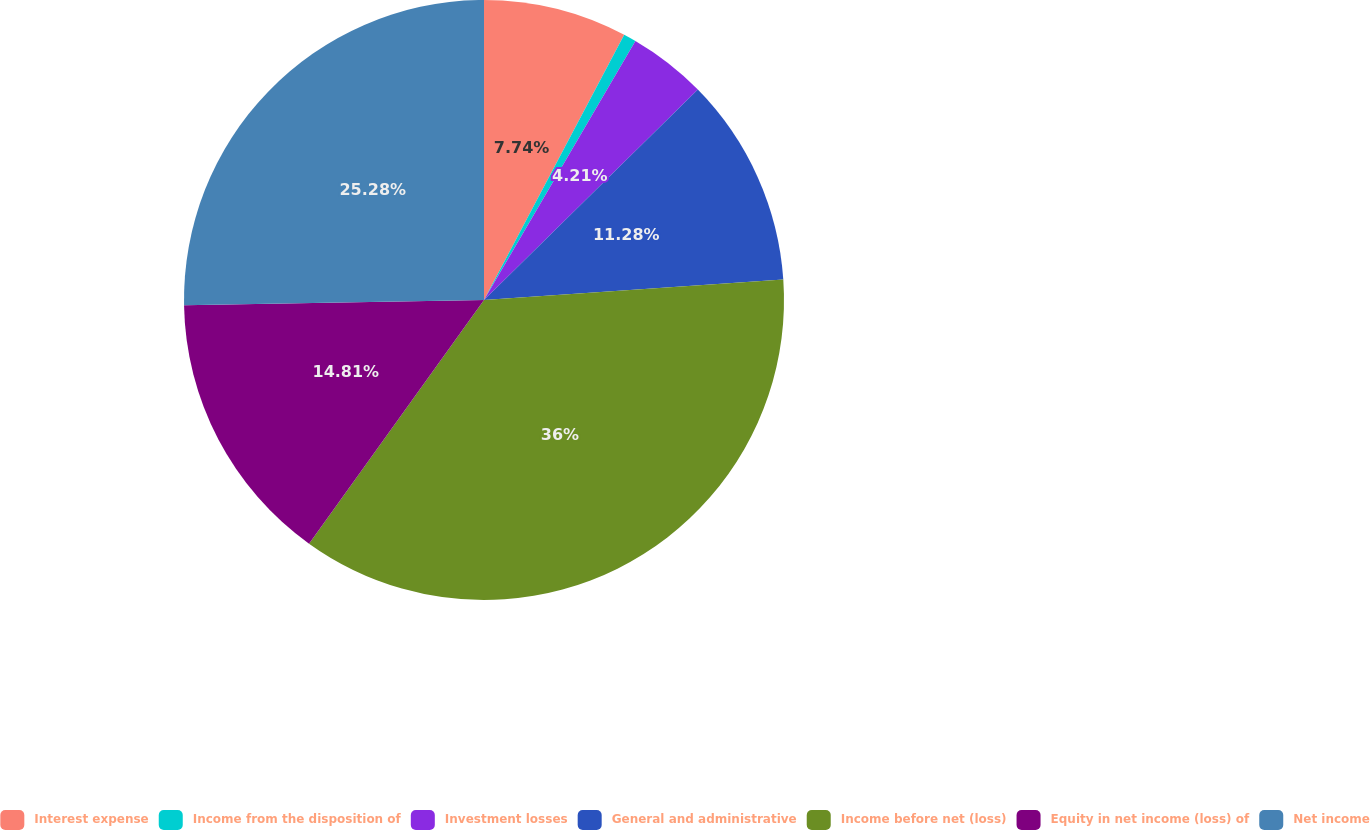Convert chart to OTSL. <chart><loc_0><loc_0><loc_500><loc_500><pie_chart><fcel>Interest expense<fcel>Income from the disposition of<fcel>Investment losses<fcel>General and administrative<fcel>Income before net (loss)<fcel>Equity in net income (loss) of<fcel>Net income<nl><fcel>7.74%<fcel>0.68%<fcel>4.21%<fcel>11.28%<fcel>36.0%<fcel>14.81%<fcel>25.28%<nl></chart> 